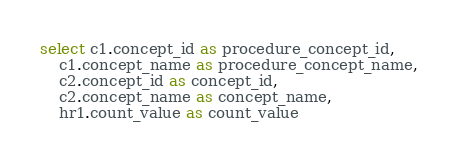<code> <loc_0><loc_0><loc_500><loc_500><_SQL_>select c1.concept_id as procedure_concept_id, 
	c1.concept_name as procedure_concept_name,
	c2.concept_id as concept_id,
	c2.concept_name as concept_name, 
	hr1.count_value as count_value</code> 